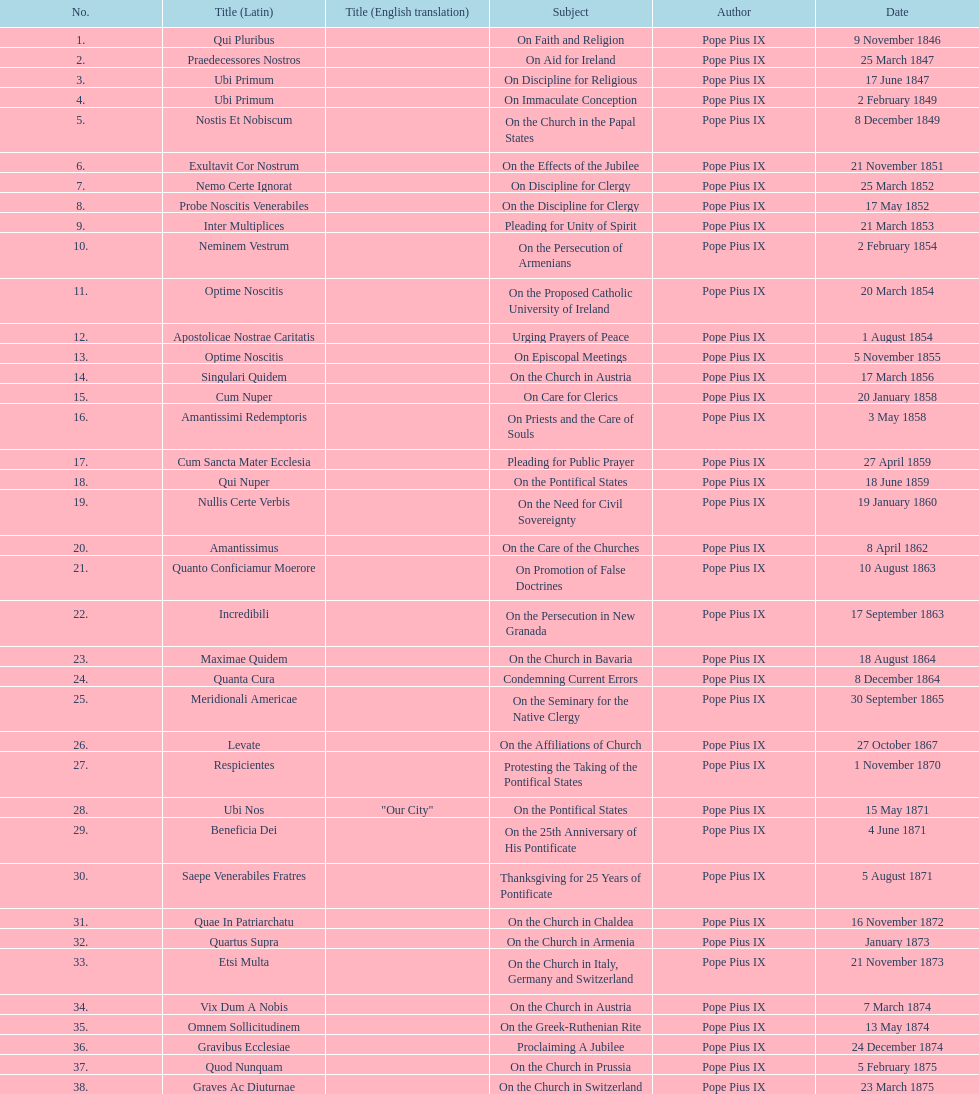How often was an encyclical sent in january? 3. 